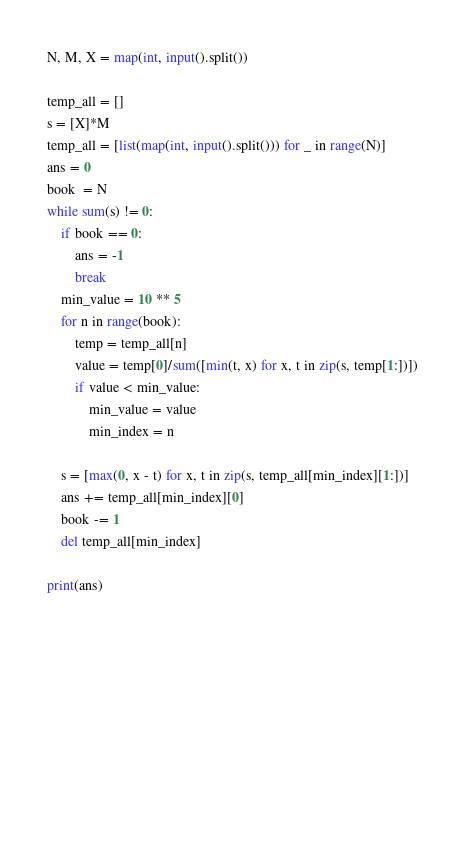<code> <loc_0><loc_0><loc_500><loc_500><_Python_>N, M, X = map(int, input().split())

temp_all = []
s = [X]*M
temp_all = [list(map(int, input().split())) for _ in range(N)]
ans = 0
book  = N
while sum(s) != 0:
    if book == 0:
        ans = -1
        break
    min_value = 10 ** 5
    for n in range(book):
        temp = temp_all[n]
        value = temp[0]/sum([min(t, x) for x, t in zip(s, temp[1:])])
        if value < min_value:
            min_value = value
            min_index = n

    s = [max(0, x - t) for x, t in zip(s, temp_all[min_index][1:])]
    ans += temp_all[min_index][0]
    book -= 1
    del temp_all[min_index]

print(ans)









    
</code> 